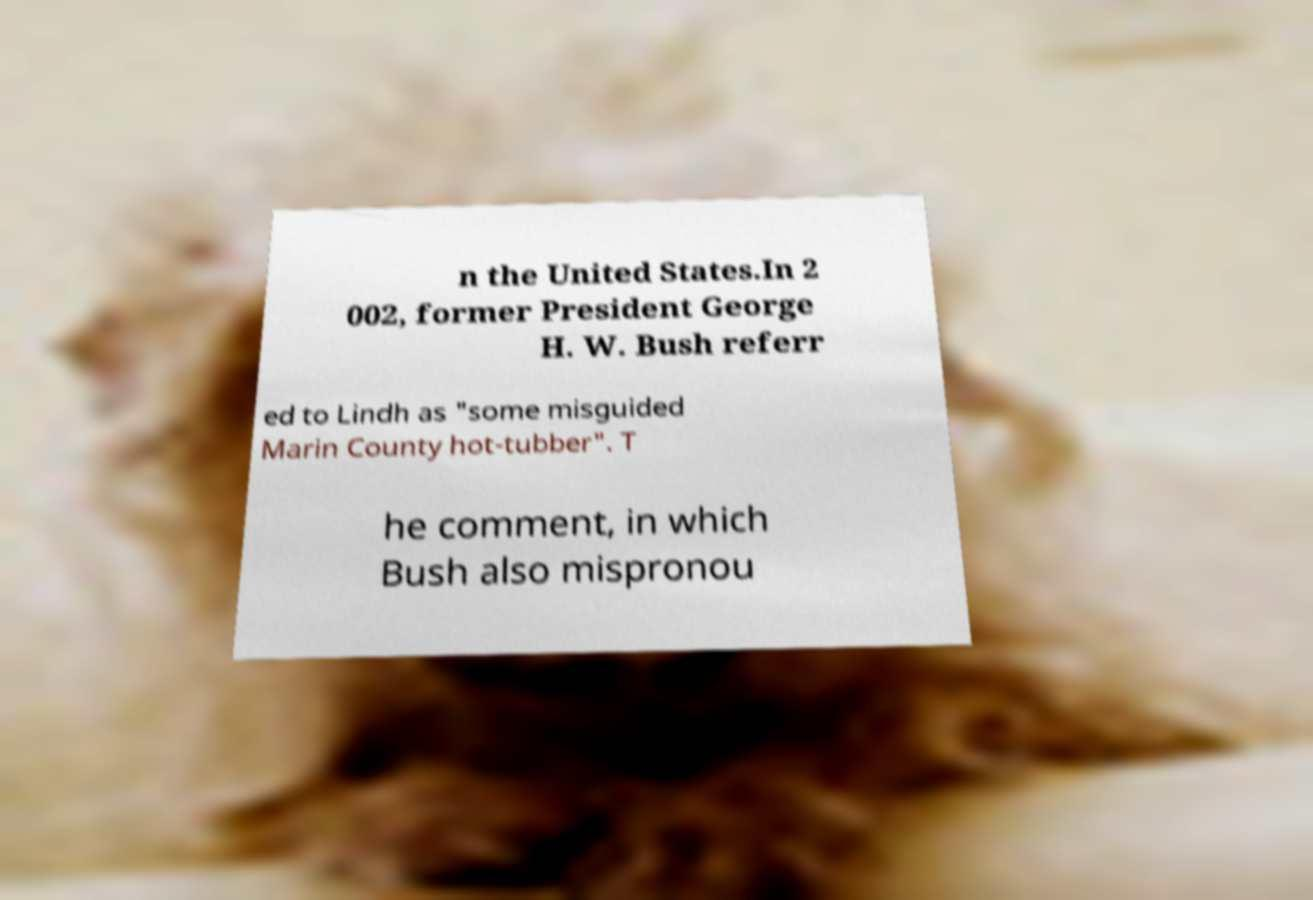What messages or text are displayed in this image? I need them in a readable, typed format. n the United States.In 2 002, former President George H. W. Bush referr ed to Lindh as "some misguided Marin County hot-tubber". T he comment, in which Bush also mispronou 